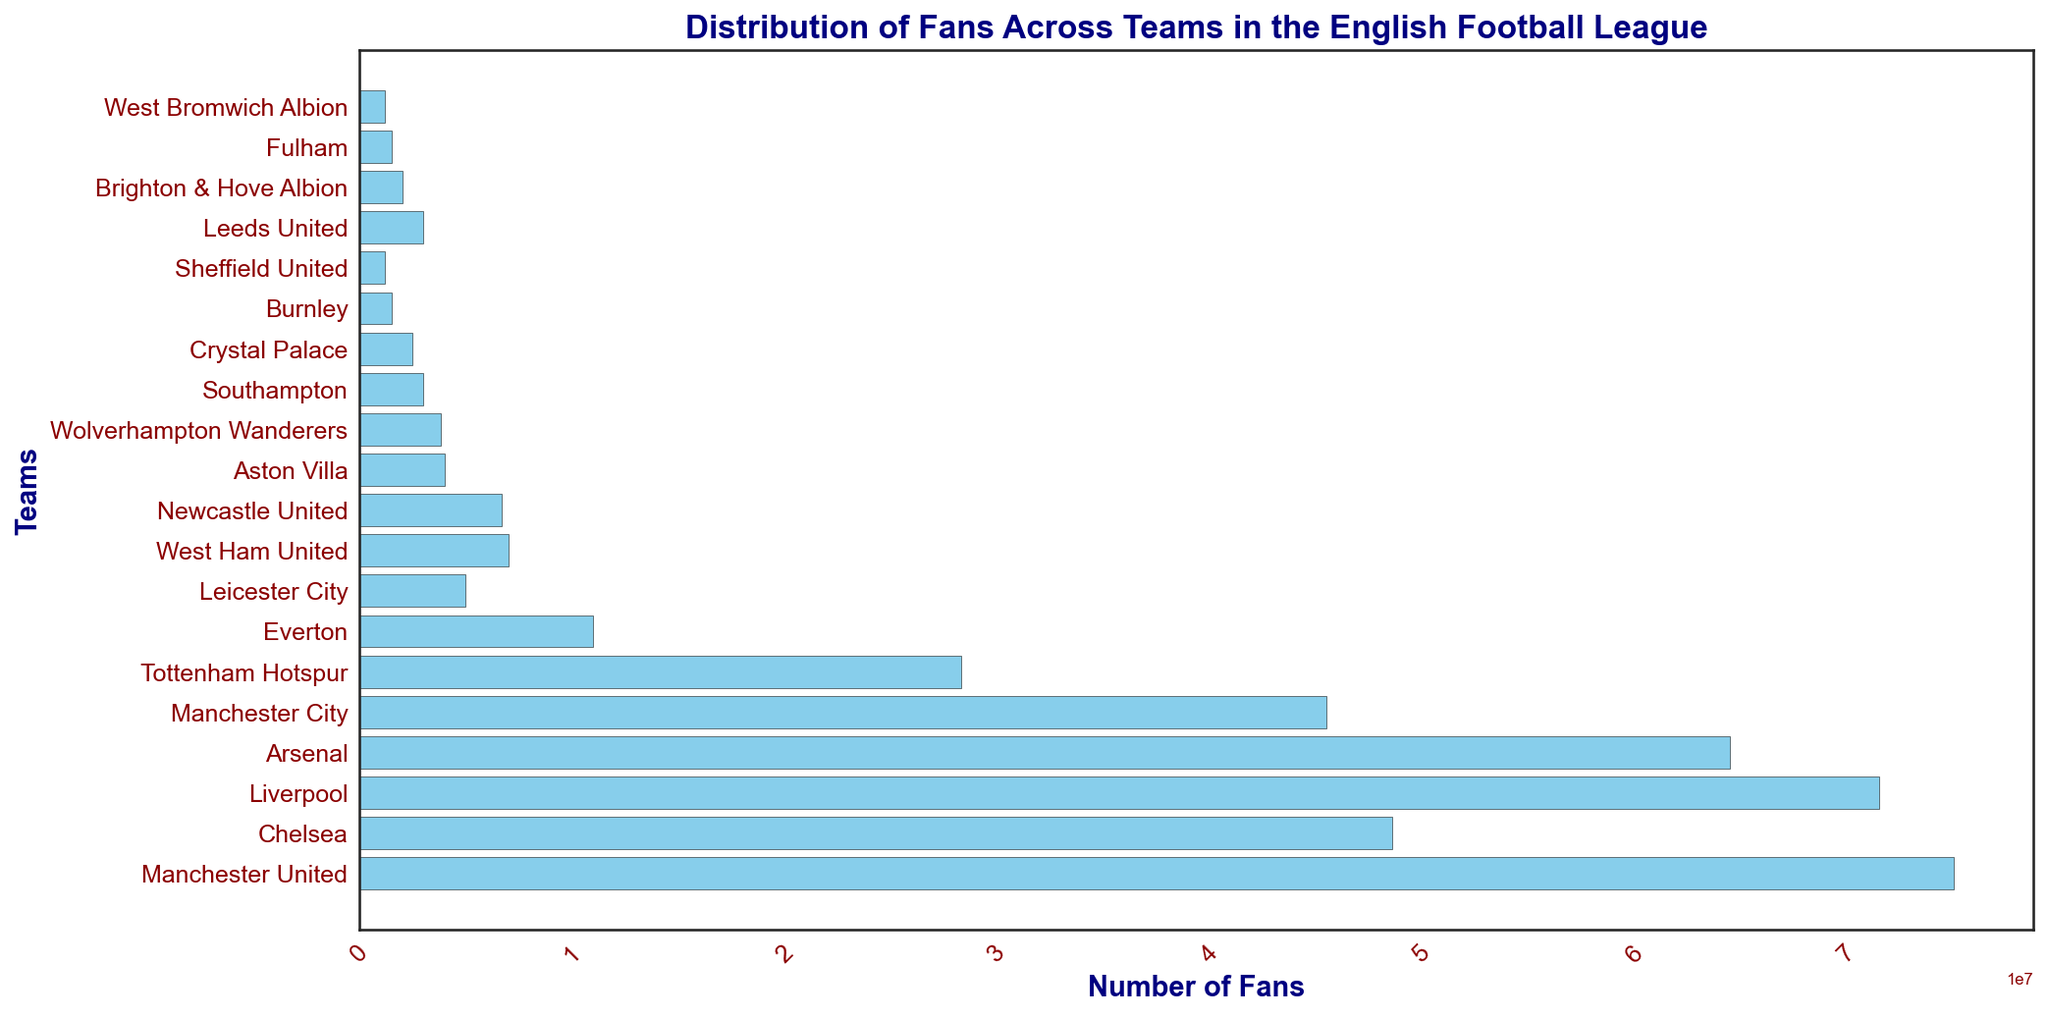Which team has the highest number of fans? Look at the length of the bars and identify the longest one. The longest bar represents Manchester United, indicating the highest number of fans.
Answer: Manchester United How many fans do the top two teams have combined? The top two teams are Manchester United and Liverpool. They have 75,000,000 and 71,500,000 fans respectively. Adding them gives 75,000,000 + 71,500,000 = 146,500,000.
Answer: 146,500,000 Which team has fewer fans: West Ham United or Leicester City? Compare the length of the bars for West Ham United and Leicester City. West Ham United has 7,000,000 fans, while Leicester City has 5,000,000 fans.
Answer: Leicester City How does the number of fans for Fulham compare to Crystal Palace? Fulham has a bar length representing 1,500,000 fans, while Crystal Palace’s bar represents 2,500,000 fans. Crystal Palace has more fans.
Answer: Fulham has fewer fans What fraction of Manchester City's fans does Everton have? Manchester City has 45,500,000 fans, and Everton has 11,000,000 fans. The fraction is calculated as 11,000,000 / 45,500,000 = 0.242.
Answer: Approximately 0.24 or 24% Arrange Tottenham Hotspur, Everton, and Aston Villa by number of fans in descending order. Looking at the bar lengths, Tottenham Hotspur has 28,300,000 fans, Everton has 11,000,000, and Aston Villa has 4,000,000. In descending order: Tottenham Hotspur, Everton, Aston Villa.
Answer: Tottenham Hotspur, Everton, Aston Villa What is the average number of fans for Manchester United, Liverpool, and Arsenal? The number of fans for these teams are 75,000,000, 71,500,000, and 64,484,940 respectively. Sum them and divide by 3: (75,000,000 + 71,500,000 + 64,484,940) / 3 ≈ 70,328,313.
Answer: Approximately 70,328,313 How many times more fans does Manchester United have compared to Sheffield United? Manchester United has 75,000,000 fans, and Sheffield United has 1,200,000 fans. The ratio is 75,000,000 / 1,200,000 = 62.5 times more.
Answer: 62.5 times What is the difference in the number of fans between Brighton & Hove Albion and Wolverhampton Wanderers? Brighton & Hove Albion has 2,000,000 fans, while Wolverhampton Wanderers has 3,800,000 fans. The difference is 3,800,000 - 2,000,000 = 1,800,000.
Answer: 1,800,000 Which team is at the median position in terms of fan count? To find the median, list all teams in order of fans and find the middle one. With 20 teams, the median position is the 10th and 11th teams (Newcastle United and Aston Villa). Between them, the median value usually refers to the lower middle one.
Answer: Newcastle United 